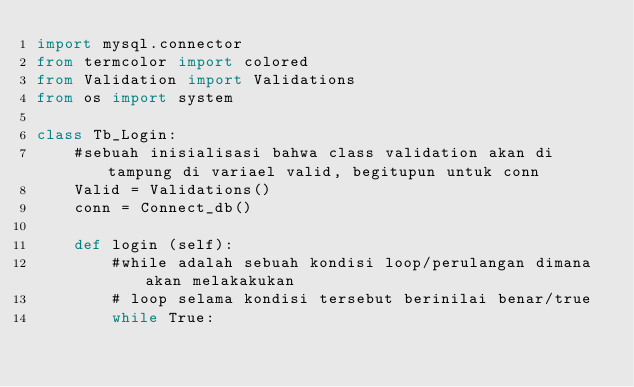<code> <loc_0><loc_0><loc_500><loc_500><_Python_>import mysql.connector
from termcolor import colored
from Validation import Validations
from os import system

class Tb_Login:
    #sebuah inisialisasi bahwa class validation akan di tampung di variael valid, begitupun untuk conn
    Valid = Validations()
    conn = Connect_db()

    def login (self):
        #while adalah sebuah kondisi loop/perulangan dimana akan melakakukan
        # loop selama kondisi tersebut berinilai benar/true
        while True:</code> 